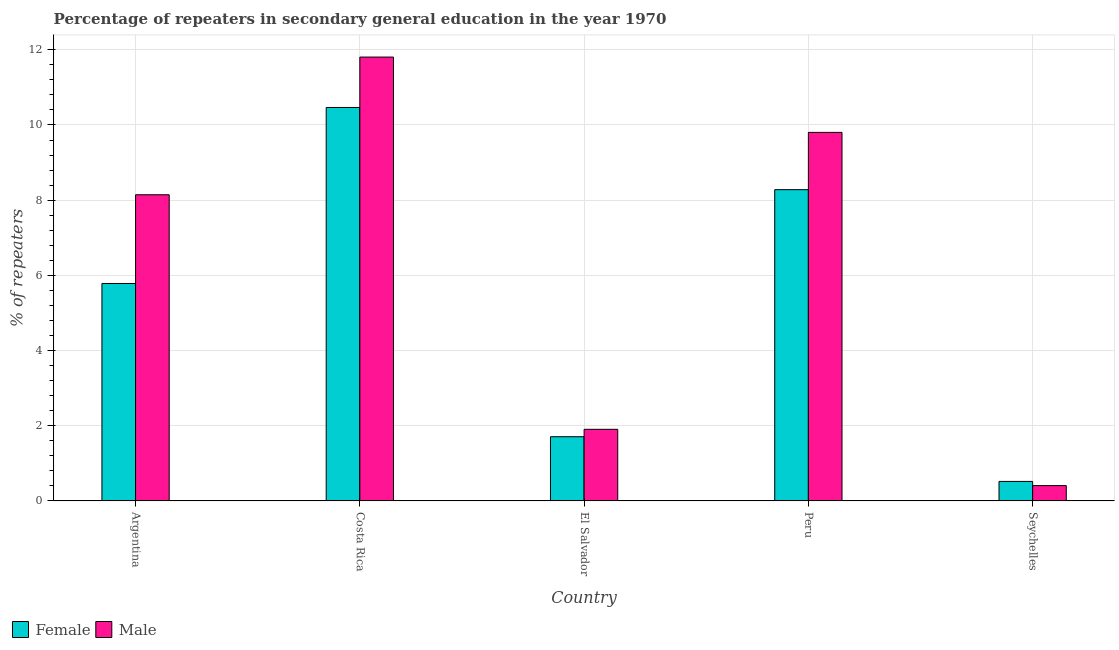How many groups of bars are there?
Provide a short and direct response. 5. How many bars are there on the 5th tick from the left?
Your response must be concise. 2. How many bars are there on the 3rd tick from the right?
Make the answer very short. 2. What is the percentage of female repeaters in Peru?
Give a very brief answer. 8.28. Across all countries, what is the maximum percentage of female repeaters?
Your response must be concise. 10.47. Across all countries, what is the minimum percentage of female repeaters?
Offer a terse response. 0.52. In which country was the percentage of female repeaters minimum?
Provide a succinct answer. Seychelles. What is the total percentage of female repeaters in the graph?
Provide a succinct answer. 26.76. What is the difference between the percentage of female repeaters in Argentina and that in Peru?
Offer a very short reply. -2.5. What is the difference between the percentage of male repeaters in Seychelles and the percentage of female repeaters in Peru?
Keep it short and to the point. -7.87. What is the average percentage of male repeaters per country?
Ensure brevity in your answer.  6.41. What is the difference between the percentage of male repeaters and percentage of female repeaters in Peru?
Your answer should be compact. 1.52. What is the ratio of the percentage of male repeaters in Argentina to that in Costa Rica?
Keep it short and to the point. 0.69. What is the difference between the highest and the second highest percentage of male repeaters?
Your response must be concise. 2. What is the difference between the highest and the lowest percentage of male repeaters?
Provide a succinct answer. 11.4. Is the sum of the percentage of male repeaters in Argentina and Costa Rica greater than the maximum percentage of female repeaters across all countries?
Provide a short and direct response. Yes. Are the values on the major ticks of Y-axis written in scientific E-notation?
Offer a very short reply. No. Does the graph contain any zero values?
Make the answer very short. No. Where does the legend appear in the graph?
Your response must be concise. Bottom left. How many legend labels are there?
Your response must be concise. 2. What is the title of the graph?
Offer a terse response. Percentage of repeaters in secondary general education in the year 1970. Does "Formally registered" appear as one of the legend labels in the graph?
Your response must be concise. No. What is the label or title of the X-axis?
Keep it short and to the point. Country. What is the label or title of the Y-axis?
Keep it short and to the point. % of repeaters. What is the % of repeaters of Female in Argentina?
Keep it short and to the point. 5.78. What is the % of repeaters in Male in Argentina?
Give a very brief answer. 8.14. What is the % of repeaters of Female in Costa Rica?
Make the answer very short. 10.47. What is the % of repeaters of Male in Costa Rica?
Provide a succinct answer. 11.81. What is the % of repeaters of Female in El Salvador?
Ensure brevity in your answer.  1.71. What is the % of repeaters of Male in El Salvador?
Provide a short and direct response. 1.91. What is the % of repeaters in Female in Peru?
Provide a short and direct response. 8.28. What is the % of repeaters in Male in Peru?
Provide a short and direct response. 9.8. What is the % of repeaters of Female in Seychelles?
Your response must be concise. 0.52. What is the % of repeaters of Male in Seychelles?
Keep it short and to the point. 0.41. Across all countries, what is the maximum % of repeaters in Female?
Offer a very short reply. 10.47. Across all countries, what is the maximum % of repeaters in Male?
Offer a very short reply. 11.81. Across all countries, what is the minimum % of repeaters in Female?
Provide a short and direct response. 0.52. Across all countries, what is the minimum % of repeaters of Male?
Give a very brief answer. 0.41. What is the total % of repeaters in Female in the graph?
Your response must be concise. 26.76. What is the total % of repeaters in Male in the graph?
Make the answer very short. 32.07. What is the difference between the % of repeaters in Female in Argentina and that in Costa Rica?
Offer a terse response. -4.68. What is the difference between the % of repeaters in Male in Argentina and that in Costa Rica?
Offer a terse response. -3.66. What is the difference between the % of repeaters in Female in Argentina and that in El Salvador?
Give a very brief answer. 4.08. What is the difference between the % of repeaters of Male in Argentina and that in El Salvador?
Keep it short and to the point. 6.24. What is the difference between the % of repeaters in Female in Argentina and that in Peru?
Make the answer very short. -2.5. What is the difference between the % of repeaters of Male in Argentina and that in Peru?
Ensure brevity in your answer.  -1.66. What is the difference between the % of repeaters in Female in Argentina and that in Seychelles?
Ensure brevity in your answer.  5.26. What is the difference between the % of repeaters of Male in Argentina and that in Seychelles?
Your response must be concise. 7.73. What is the difference between the % of repeaters of Female in Costa Rica and that in El Salvador?
Keep it short and to the point. 8.76. What is the difference between the % of repeaters in Male in Costa Rica and that in El Salvador?
Make the answer very short. 9.9. What is the difference between the % of repeaters in Female in Costa Rica and that in Peru?
Provide a succinct answer. 2.19. What is the difference between the % of repeaters of Male in Costa Rica and that in Peru?
Keep it short and to the point. 2. What is the difference between the % of repeaters of Female in Costa Rica and that in Seychelles?
Keep it short and to the point. 9.95. What is the difference between the % of repeaters in Male in Costa Rica and that in Seychelles?
Your response must be concise. 11.4. What is the difference between the % of repeaters in Female in El Salvador and that in Peru?
Keep it short and to the point. -6.57. What is the difference between the % of repeaters of Male in El Salvador and that in Peru?
Your answer should be very brief. -7.9. What is the difference between the % of repeaters in Female in El Salvador and that in Seychelles?
Your response must be concise. 1.19. What is the difference between the % of repeaters in Male in El Salvador and that in Seychelles?
Make the answer very short. 1.5. What is the difference between the % of repeaters of Female in Peru and that in Seychelles?
Offer a very short reply. 7.76. What is the difference between the % of repeaters of Male in Peru and that in Seychelles?
Provide a short and direct response. 9.39. What is the difference between the % of repeaters of Female in Argentina and the % of repeaters of Male in Costa Rica?
Offer a terse response. -6.02. What is the difference between the % of repeaters in Female in Argentina and the % of repeaters in Male in El Salvador?
Ensure brevity in your answer.  3.88. What is the difference between the % of repeaters in Female in Argentina and the % of repeaters in Male in Peru?
Make the answer very short. -4.02. What is the difference between the % of repeaters of Female in Argentina and the % of repeaters of Male in Seychelles?
Your answer should be compact. 5.38. What is the difference between the % of repeaters of Female in Costa Rica and the % of repeaters of Male in El Salvador?
Your answer should be compact. 8.56. What is the difference between the % of repeaters in Female in Costa Rica and the % of repeaters in Male in Peru?
Give a very brief answer. 0.66. What is the difference between the % of repeaters in Female in Costa Rica and the % of repeaters in Male in Seychelles?
Offer a terse response. 10.06. What is the difference between the % of repeaters of Female in El Salvador and the % of repeaters of Male in Peru?
Offer a terse response. -8.09. What is the difference between the % of repeaters in Female in El Salvador and the % of repeaters in Male in Seychelles?
Ensure brevity in your answer.  1.3. What is the difference between the % of repeaters of Female in Peru and the % of repeaters of Male in Seychelles?
Your answer should be compact. 7.87. What is the average % of repeaters in Female per country?
Your answer should be compact. 5.35. What is the average % of repeaters of Male per country?
Keep it short and to the point. 6.41. What is the difference between the % of repeaters in Female and % of repeaters in Male in Argentina?
Give a very brief answer. -2.36. What is the difference between the % of repeaters of Female and % of repeaters of Male in Costa Rica?
Provide a short and direct response. -1.34. What is the difference between the % of repeaters in Female and % of repeaters in Male in El Salvador?
Provide a short and direct response. -0.2. What is the difference between the % of repeaters in Female and % of repeaters in Male in Peru?
Your answer should be very brief. -1.52. What is the difference between the % of repeaters in Female and % of repeaters in Male in Seychelles?
Offer a very short reply. 0.11. What is the ratio of the % of repeaters of Female in Argentina to that in Costa Rica?
Provide a succinct answer. 0.55. What is the ratio of the % of repeaters of Male in Argentina to that in Costa Rica?
Keep it short and to the point. 0.69. What is the ratio of the % of repeaters in Female in Argentina to that in El Salvador?
Ensure brevity in your answer.  3.38. What is the ratio of the % of repeaters in Male in Argentina to that in El Salvador?
Keep it short and to the point. 4.27. What is the ratio of the % of repeaters in Female in Argentina to that in Peru?
Offer a very short reply. 0.7. What is the ratio of the % of repeaters in Male in Argentina to that in Peru?
Your response must be concise. 0.83. What is the ratio of the % of repeaters of Female in Argentina to that in Seychelles?
Your response must be concise. 11.12. What is the ratio of the % of repeaters of Male in Argentina to that in Seychelles?
Keep it short and to the point. 19.91. What is the ratio of the % of repeaters of Female in Costa Rica to that in El Salvador?
Your answer should be compact. 6.12. What is the ratio of the % of repeaters in Male in Costa Rica to that in El Salvador?
Provide a succinct answer. 6.19. What is the ratio of the % of repeaters of Female in Costa Rica to that in Peru?
Your response must be concise. 1.26. What is the ratio of the % of repeaters in Male in Costa Rica to that in Peru?
Give a very brief answer. 1.2. What is the ratio of the % of repeaters in Female in Costa Rica to that in Seychelles?
Your answer should be very brief. 20.11. What is the ratio of the % of repeaters of Male in Costa Rica to that in Seychelles?
Your answer should be compact. 28.86. What is the ratio of the % of repeaters of Female in El Salvador to that in Peru?
Offer a terse response. 0.21. What is the ratio of the % of repeaters in Male in El Salvador to that in Peru?
Provide a short and direct response. 0.19. What is the ratio of the % of repeaters of Female in El Salvador to that in Seychelles?
Make the answer very short. 3.28. What is the ratio of the % of repeaters of Male in El Salvador to that in Seychelles?
Make the answer very short. 4.66. What is the ratio of the % of repeaters in Female in Peru to that in Seychelles?
Your answer should be very brief. 15.91. What is the ratio of the % of repeaters of Male in Peru to that in Seychelles?
Your response must be concise. 23.97. What is the difference between the highest and the second highest % of repeaters in Female?
Offer a very short reply. 2.19. What is the difference between the highest and the second highest % of repeaters of Male?
Provide a short and direct response. 2. What is the difference between the highest and the lowest % of repeaters in Female?
Make the answer very short. 9.95. What is the difference between the highest and the lowest % of repeaters of Male?
Your answer should be compact. 11.4. 